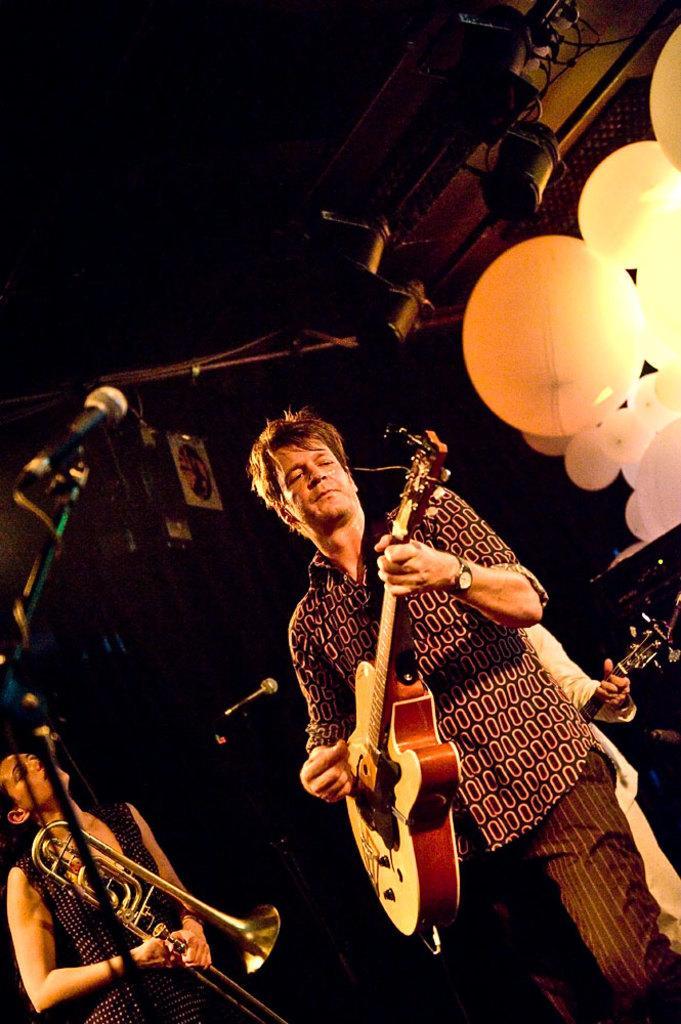How would you summarize this image in a sentence or two? In the middle of the image a man is standing and playing guitar. Behind him there is a person holding a guitar. Bottom left side of the image a woman is a standing and holding a musical instrument. Top left side of the image there is a microphone. Top right side of the image there are few balloons. 